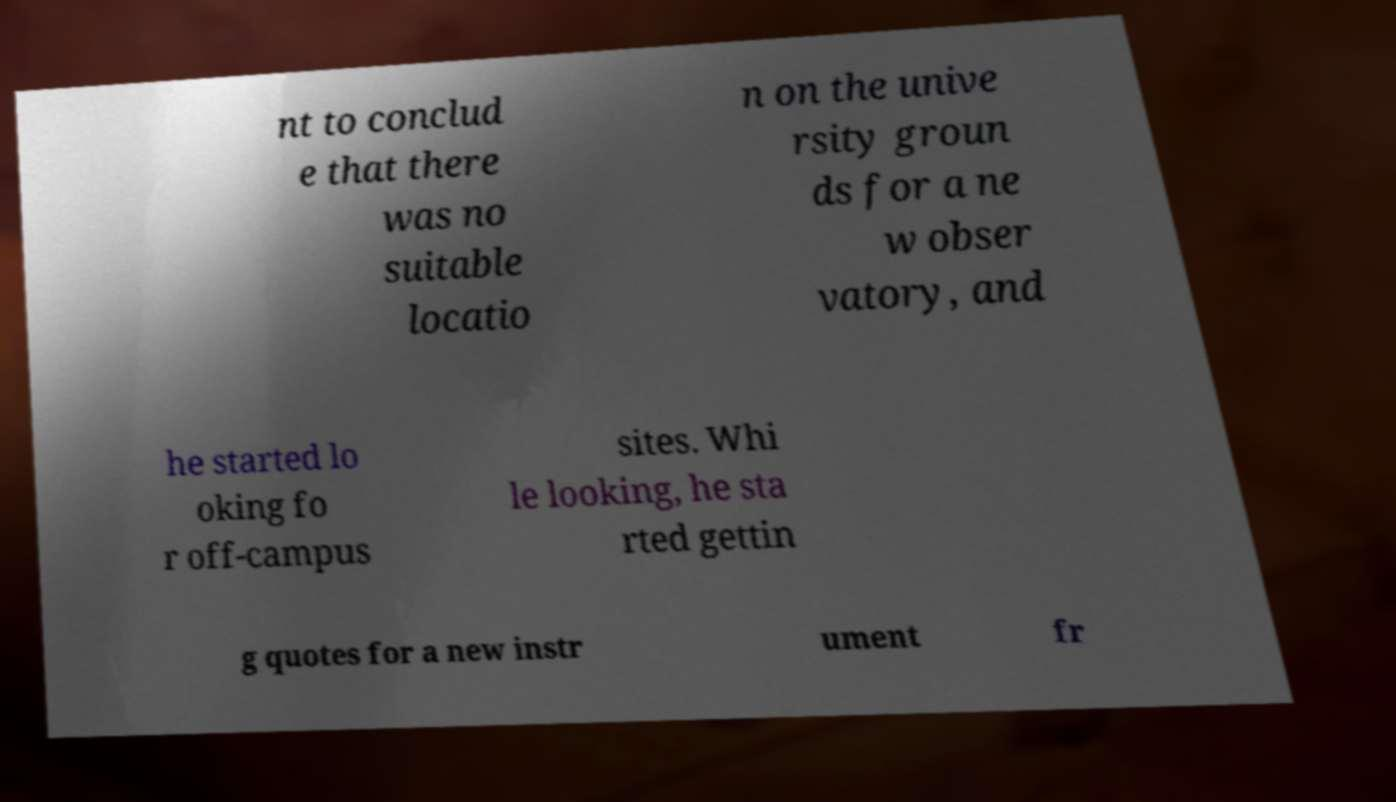Can you read and provide the text displayed in the image?This photo seems to have some interesting text. Can you extract and type it out for me? nt to conclud e that there was no suitable locatio n on the unive rsity groun ds for a ne w obser vatory, and he started lo oking fo r off-campus sites. Whi le looking, he sta rted gettin g quotes for a new instr ument fr 